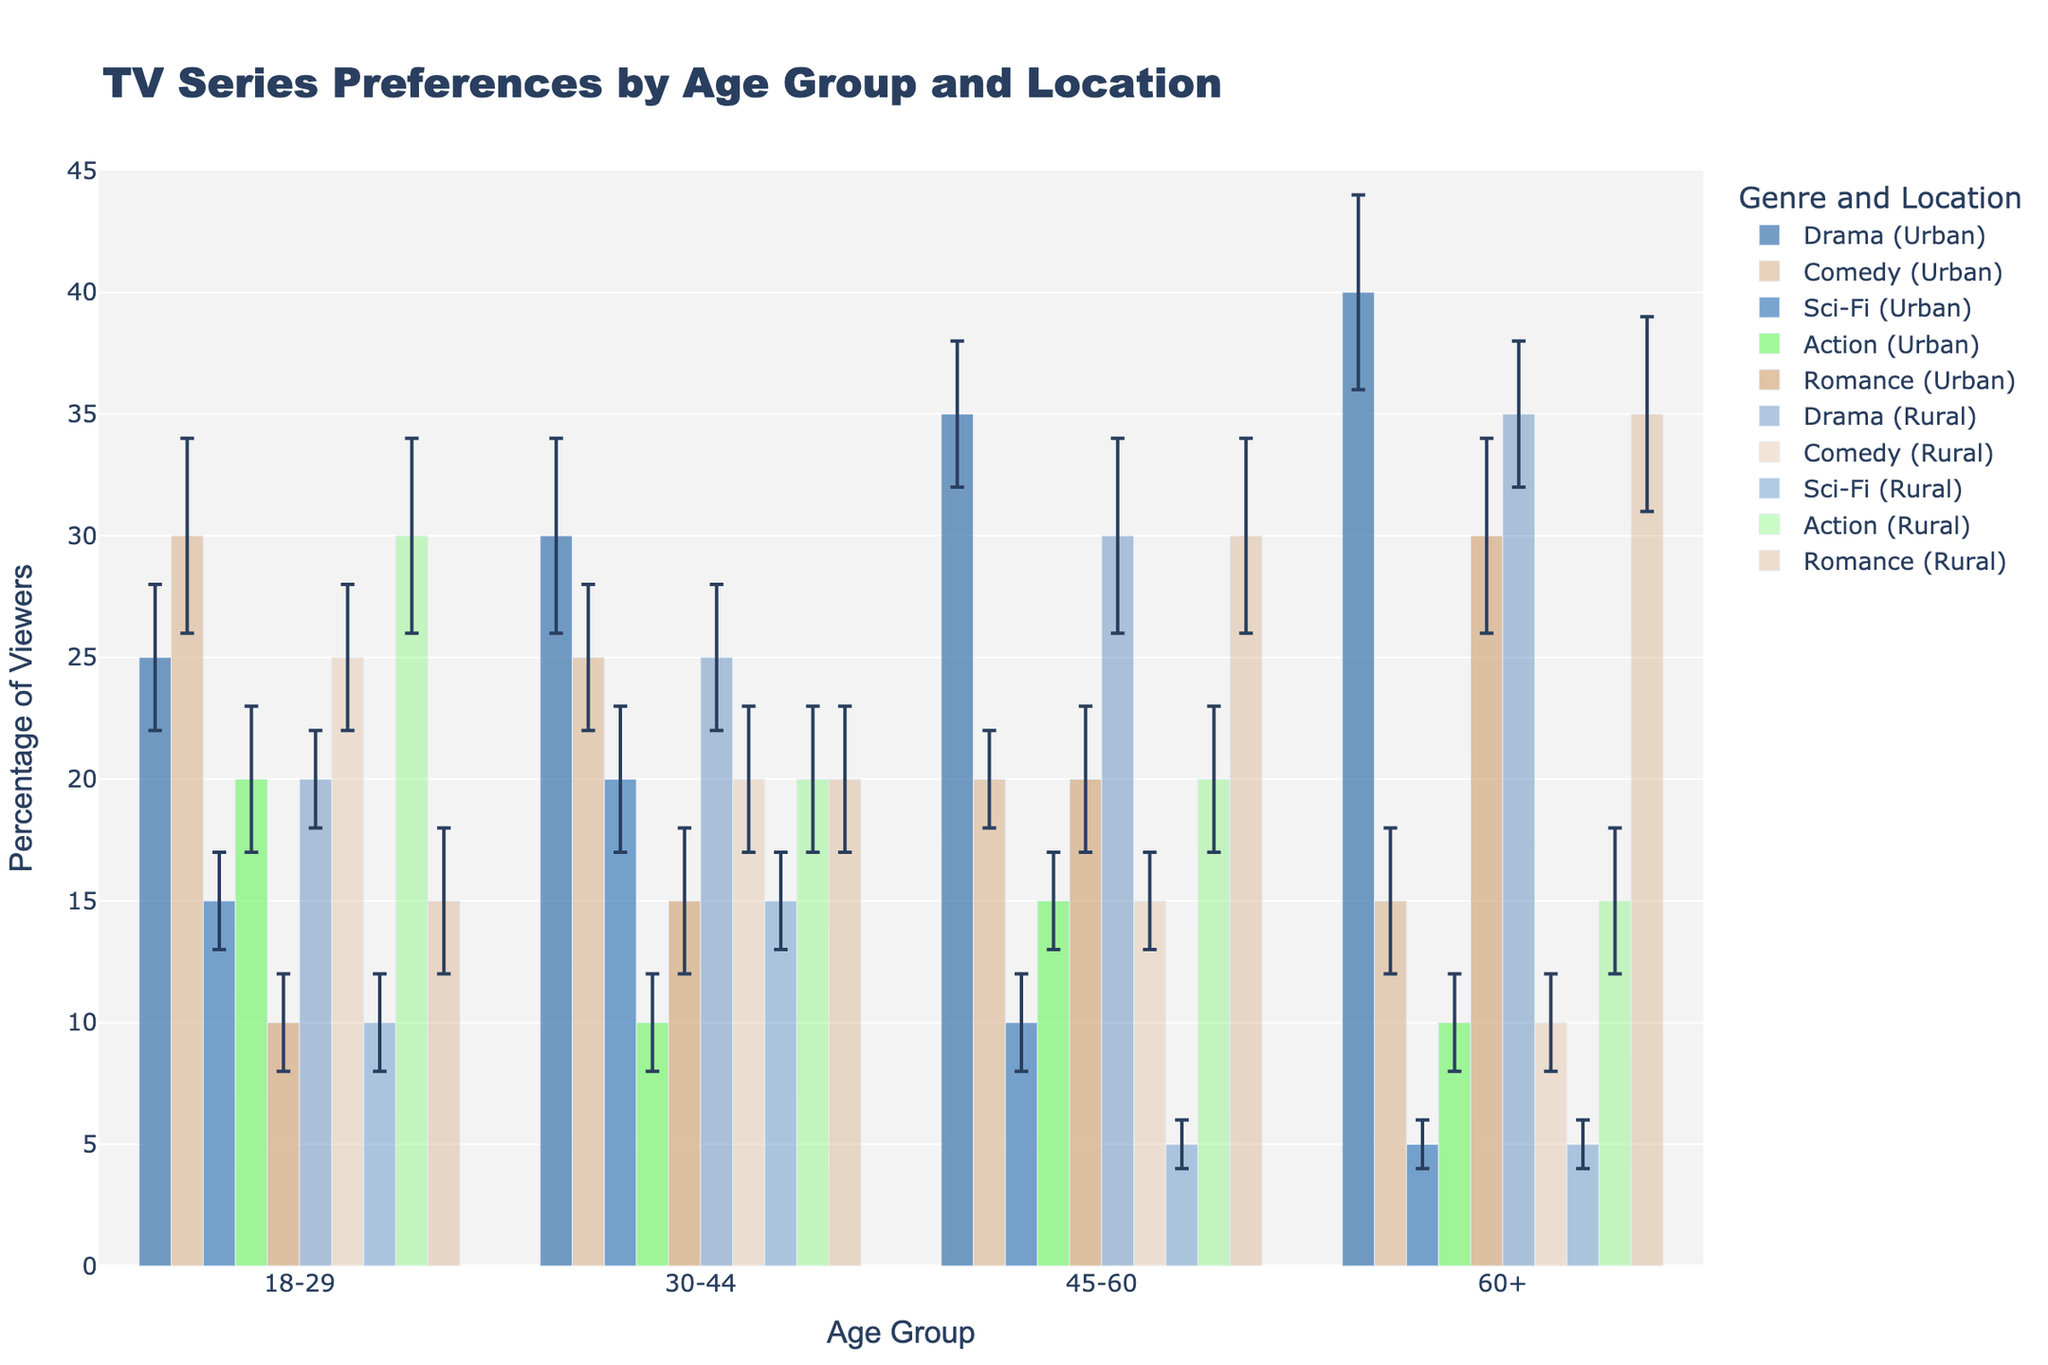What's the title of the figure? The title of the figure is prominently displayed at the top. It reads "TV Series Preferences by Age Group and Location".
Answer: TV Series Preferences by Age Group and Location Which age group has the highest percentage of urban viewers who prefer drama? Look for the orange-colored bar representing 'Drama (Urban)' and compare the height of these bars across different age groups. The highest bar is in the '60+' age group.
Answer: 60+ What is the error margin for comedy preferences among rural viewers aged 18-29? Locate the bar for 'Comedy (Rural)' under the '18-29' age group. The error margin is indicated as an error bar attached to the top of the bar representing 'Comedy (Rural)', which is 3.
Answer: 3 Compare the preferences for romance between urban and rural viewers aged 45-60? Identify the bars for 'Romance (Urban)' and 'Romance (Rural)' under the '45-60' age group. 'Romance (Rural)' has a higher percentage (30%) than 'Romance (Urban)' (20%).
Answer: 30% (Rural) > 20% (Urban) What is the combined percentage of urban viewers aged 30-44 who prefer sci-fi and action? Add the percentages for 'Sci-Fi (Urban)' and 'Action (Urban)' under the '30-44' age group: 20% (Sci-Fi) + 10% (Action) = 30%.
Answer: 30% Does any age group of rural viewers have a higher percentage for action preference than urban viewers of the same age group? Compare each age group's bars for 'Action (Urban)' and 'Action (Rural)'. Only the '18-29' age group shows that rural viewers (30%) prefer action more than urban viewers (20%).
Answer: 18-29 For urban viewers aged 60+, which genre has the lowest preference percentage? Look at the '60+' age group under 'Urban' and find the genre with the smallest bar. 'Sci-Fi (Urban)' has the lowest preference percentage, which is 5%.
Answer: Sci-Fi What is the difference in percentage viewers for drama between urban and rural viewers aged 45-60? Find the percentages for 'Drama (Urban)' and 'Drama (Rural)' in the '45-60' age group. The difference is calculated as 35% (Urban) - 30% (Rural) = 5%.
Answer: 5% Which genre shows a significant difference in preferences for rural viewers aged 60+ compared to those aged 18-29? Compare the bars between '60+ Rural' and '18-29 Rural' across all genres. 'Romance (Rural)' shows a significant difference, being much higher in '60+' (35%) than '18-29' (15%).
Answer: Romance What age group of urban viewers has the largest error margin for comedy preferences? Examine the error bars attached to the 'Comedy (Urban)' bars across all age groups. The '18-29' age group has the largest error margin, which is 4.
Answer: 18-29 